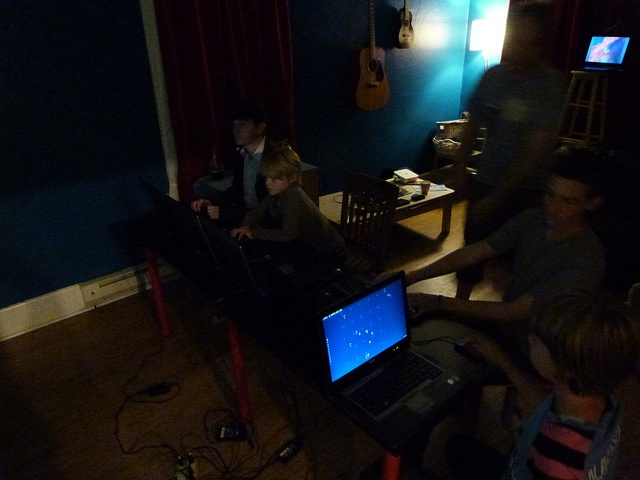Describe the objects in this image and their specific colors. I can see people in black, maroon, and gray tones, people in black, olive, and tan tones, laptop in black, blue, darkblue, and lightblue tones, people in black, darkgreen, and gray tones, and people in black, maroon, and olive tones in this image. 